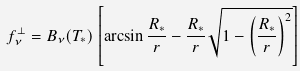<formula> <loc_0><loc_0><loc_500><loc_500>f ^ { \perp } _ { \nu } = B _ { \nu } ( T _ { * } ) \left [ \arcsin \frac { R _ { * } } { r } - \frac { R _ { * } } { r } \sqrt { 1 - \left ( \frac { R _ { * } } { r } \right ) ^ { 2 } } \right ]</formula> 